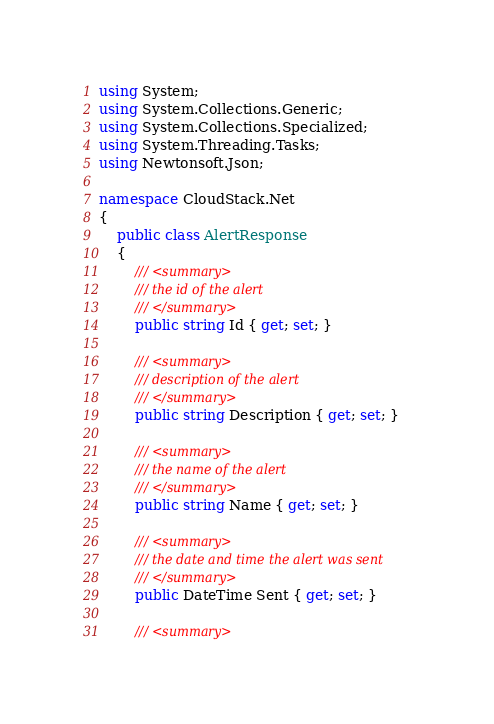<code> <loc_0><loc_0><loc_500><loc_500><_C#_>using System;
using System.Collections.Generic;
using System.Collections.Specialized;
using System.Threading.Tasks;
using Newtonsoft.Json;

namespace CloudStack.Net
{
    public class AlertResponse
    {
        /// <summary>
        /// the id of the alert
        /// </summary>
        public string Id { get; set; }

        /// <summary>
        /// description of the alert
        /// </summary>
        public string Description { get; set; }

        /// <summary>
        /// the name of the alert
        /// </summary>
        public string Name { get; set; }

        /// <summary>
        /// the date and time the alert was sent
        /// </summary>
        public DateTime Sent { get; set; }

        /// <summary></code> 